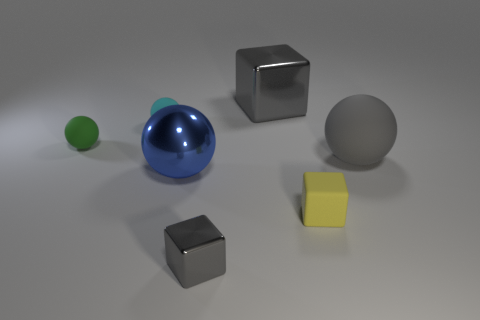Subtract all tiny green balls. How many balls are left? 3 Subtract all cyan balls. How many gray cubes are left? 2 Subtract all blue spheres. How many spheres are left? 3 Add 3 small green things. How many objects exist? 10 Subtract all cubes. How many objects are left? 4 Add 5 tiny green rubber balls. How many tiny green rubber balls exist? 6 Subtract 0 purple cylinders. How many objects are left? 7 Subtract all blue balls. Subtract all purple cylinders. How many balls are left? 3 Subtract all big gray cubes. Subtract all blocks. How many objects are left? 3 Add 5 gray shiny cubes. How many gray shiny cubes are left? 7 